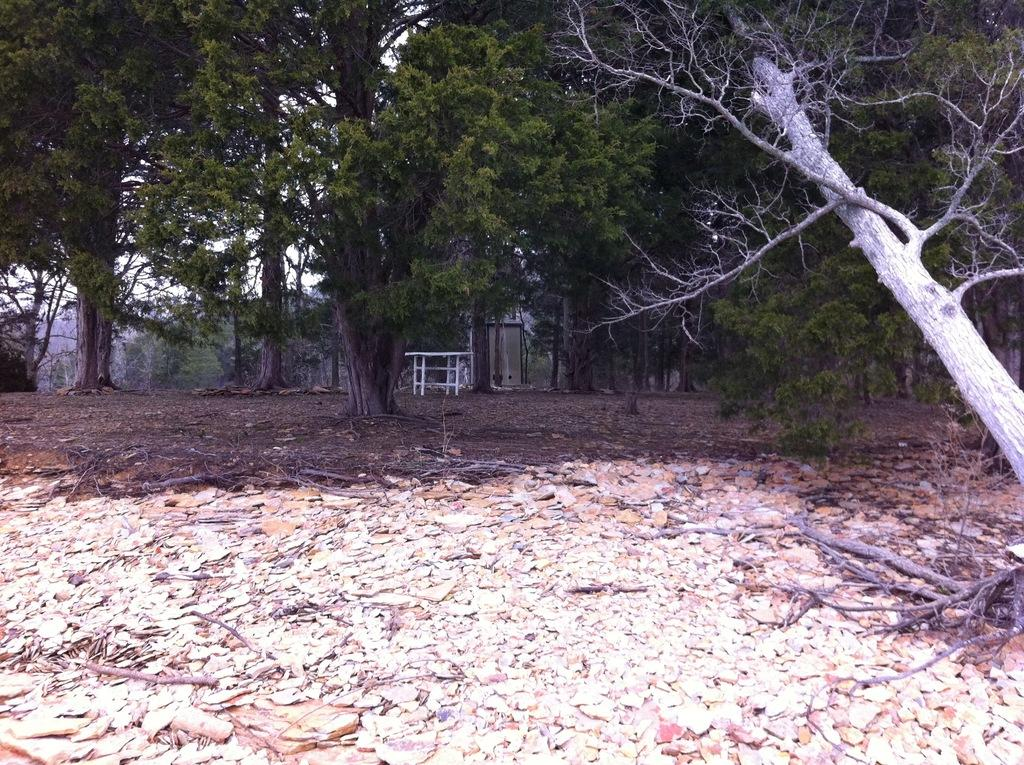What type of vegetation is present in the image? There are many trees in the image. What object can be seen in the image besides the trees? There is a table in the image. What is present on the ground in the image? Dry leaves and twigs are visible in the image. What can be seen in the background of the image? The sky is visible in the background of the image. Can you touch the trees in the image? No, you cannot touch the trees in the image, as it is a two-dimensional representation and not a physical object. 